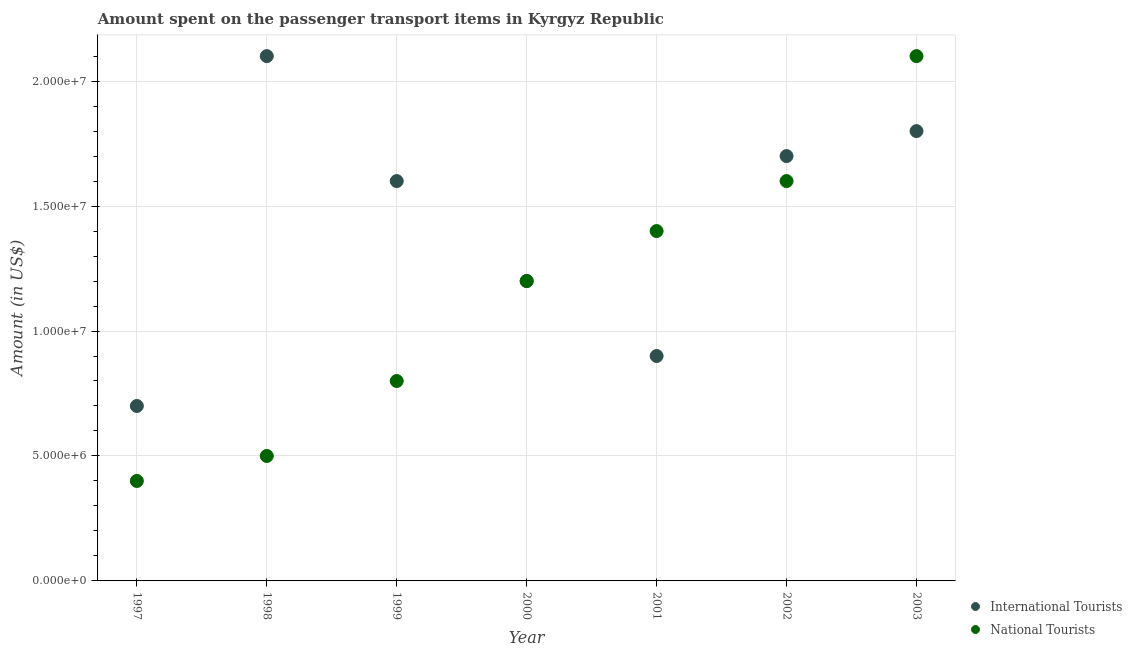Is the number of dotlines equal to the number of legend labels?
Make the answer very short. Yes. What is the amount spent on transport items of international tourists in 2001?
Provide a short and direct response. 9.00e+06. Across all years, what is the maximum amount spent on transport items of national tourists?
Your answer should be compact. 2.10e+07. Across all years, what is the minimum amount spent on transport items of national tourists?
Offer a very short reply. 4.00e+06. In which year was the amount spent on transport items of national tourists minimum?
Ensure brevity in your answer.  1997. What is the total amount spent on transport items of international tourists in the graph?
Provide a succinct answer. 1.00e+08. What is the difference between the amount spent on transport items of international tourists in 1997 and that in 2002?
Your response must be concise. -1.00e+07. What is the difference between the amount spent on transport items of national tourists in 2003 and the amount spent on transport items of international tourists in 1998?
Ensure brevity in your answer.  0. What is the average amount spent on transport items of international tourists per year?
Your response must be concise. 1.43e+07. In the year 1997, what is the difference between the amount spent on transport items of international tourists and amount spent on transport items of national tourists?
Make the answer very short. 3.00e+06. In how many years, is the amount spent on transport items of international tourists greater than 1000000 US$?
Ensure brevity in your answer.  7. Is the difference between the amount spent on transport items of national tourists in 1997 and 2001 greater than the difference between the amount spent on transport items of international tourists in 1997 and 2001?
Your response must be concise. No. What is the difference between the highest and the second highest amount spent on transport items of international tourists?
Ensure brevity in your answer.  3.00e+06. What is the difference between the highest and the lowest amount spent on transport items of national tourists?
Keep it short and to the point. 1.70e+07. In how many years, is the amount spent on transport items of national tourists greater than the average amount spent on transport items of national tourists taken over all years?
Offer a very short reply. 4. Is the sum of the amount spent on transport items of national tourists in 2002 and 2003 greater than the maximum amount spent on transport items of international tourists across all years?
Offer a terse response. Yes. Is the amount spent on transport items of international tourists strictly greater than the amount spent on transport items of national tourists over the years?
Provide a short and direct response. No. How many dotlines are there?
Keep it short and to the point. 2. What is the difference between two consecutive major ticks on the Y-axis?
Offer a terse response. 5.00e+06. Are the values on the major ticks of Y-axis written in scientific E-notation?
Ensure brevity in your answer.  Yes. Does the graph contain grids?
Provide a short and direct response. Yes. Where does the legend appear in the graph?
Offer a very short reply. Bottom right. How are the legend labels stacked?
Offer a terse response. Vertical. What is the title of the graph?
Offer a terse response. Amount spent on the passenger transport items in Kyrgyz Republic. What is the Amount (in US$) in International Tourists in 1997?
Your response must be concise. 7.00e+06. What is the Amount (in US$) in International Tourists in 1998?
Give a very brief answer. 2.10e+07. What is the Amount (in US$) of National Tourists in 1998?
Offer a very short reply. 5.00e+06. What is the Amount (in US$) of International Tourists in 1999?
Give a very brief answer. 1.60e+07. What is the Amount (in US$) of International Tourists in 2000?
Offer a terse response. 1.20e+07. What is the Amount (in US$) in International Tourists in 2001?
Offer a very short reply. 9.00e+06. What is the Amount (in US$) in National Tourists in 2001?
Provide a short and direct response. 1.40e+07. What is the Amount (in US$) in International Tourists in 2002?
Your response must be concise. 1.70e+07. What is the Amount (in US$) in National Tourists in 2002?
Your response must be concise. 1.60e+07. What is the Amount (in US$) in International Tourists in 2003?
Give a very brief answer. 1.80e+07. What is the Amount (in US$) of National Tourists in 2003?
Ensure brevity in your answer.  2.10e+07. Across all years, what is the maximum Amount (in US$) of International Tourists?
Provide a succinct answer. 2.10e+07. Across all years, what is the maximum Amount (in US$) in National Tourists?
Provide a succinct answer. 2.10e+07. Across all years, what is the minimum Amount (in US$) in International Tourists?
Your answer should be compact. 7.00e+06. Across all years, what is the minimum Amount (in US$) of National Tourists?
Provide a succinct answer. 4.00e+06. What is the total Amount (in US$) in International Tourists in the graph?
Ensure brevity in your answer.  1.00e+08. What is the total Amount (in US$) in National Tourists in the graph?
Make the answer very short. 8.00e+07. What is the difference between the Amount (in US$) in International Tourists in 1997 and that in 1998?
Ensure brevity in your answer.  -1.40e+07. What is the difference between the Amount (in US$) of National Tourists in 1997 and that in 1998?
Ensure brevity in your answer.  -1.00e+06. What is the difference between the Amount (in US$) in International Tourists in 1997 and that in 1999?
Give a very brief answer. -9.00e+06. What is the difference between the Amount (in US$) in National Tourists in 1997 and that in 1999?
Give a very brief answer. -4.00e+06. What is the difference between the Amount (in US$) of International Tourists in 1997 and that in 2000?
Your response must be concise. -5.00e+06. What is the difference between the Amount (in US$) in National Tourists in 1997 and that in 2000?
Provide a succinct answer. -8.00e+06. What is the difference between the Amount (in US$) in International Tourists in 1997 and that in 2001?
Provide a short and direct response. -2.00e+06. What is the difference between the Amount (in US$) of National Tourists in 1997 and that in 2001?
Your answer should be very brief. -1.00e+07. What is the difference between the Amount (in US$) of International Tourists in 1997 and that in 2002?
Provide a short and direct response. -1.00e+07. What is the difference between the Amount (in US$) in National Tourists in 1997 and that in 2002?
Offer a terse response. -1.20e+07. What is the difference between the Amount (in US$) in International Tourists in 1997 and that in 2003?
Make the answer very short. -1.10e+07. What is the difference between the Amount (in US$) of National Tourists in 1997 and that in 2003?
Give a very brief answer. -1.70e+07. What is the difference between the Amount (in US$) of International Tourists in 1998 and that in 1999?
Provide a short and direct response. 5.00e+06. What is the difference between the Amount (in US$) of International Tourists in 1998 and that in 2000?
Keep it short and to the point. 9.00e+06. What is the difference between the Amount (in US$) in National Tourists in 1998 and that in 2000?
Ensure brevity in your answer.  -7.00e+06. What is the difference between the Amount (in US$) of National Tourists in 1998 and that in 2001?
Offer a very short reply. -9.00e+06. What is the difference between the Amount (in US$) in National Tourists in 1998 and that in 2002?
Provide a short and direct response. -1.10e+07. What is the difference between the Amount (in US$) of International Tourists in 1998 and that in 2003?
Offer a terse response. 3.00e+06. What is the difference between the Amount (in US$) of National Tourists in 1998 and that in 2003?
Your answer should be compact. -1.60e+07. What is the difference between the Amount (in US$) of International Tourists in 1999 and that in 2000?
Give a very brief answer. 4.00e+06. What is the difference between the Amount (in US$) in National Tourists in 1999 and that in 2001?
Give a very brief answer. -6.00e+06. What is the difference between the Amount (in US$) in International Tourists in 1999 and that in 2002?
Offer a very short reply. -1.00e+06. What is the difference between the Amount (in US$) of National Tourists in 1999 and that in 2002?
Your answer should be compact. -8.00e+06. What is the difference between the Amount (in US$) of National Tourists in 1999 and that in 2003?
Give a very brief answer. -1.30e+07. What is the difference between the Amount (in US$) of International Tourists in 2000 and that in 2001?
Make the answer very short. 3.00e+06. What is the difference between the Amount (in US$) of National Tourists in 2000 and that in 2001?
Your response must be concise. -2.00e+06. What is the difference between the Amount (in US$) in International Tourists in 2000 and that in 2002?
Offer a terse response. -5.00e+06. What is the difference between the Amount (in US$) in National Tourists in 2000 and that in 2002?
Give a very brief answer. -4.00e+06. What is the difference between the Amount (in US$) in International Tourists in 2000 and that in 2003?
Provide a short and direct response. -6.00e+06. What is the difference between the Amount (in US$) of National Tourists in 2000 and that in 2003?
Your answer should be compact. -9.00e+06. What is the difference between the Amount (in US$) of International Tourists in 2001 and that in 2002?
Keep it short and to the point. -8.00e+06. What is the difference between the Amount (in US$) of National Tourists in 2001 and that in 2002?
Make the answer very short. -2.00e+06. What is the difference between the Amount (in US$) in International Tourists in 2001 and that in 2003?
Give a very brief answer. -9.00e+06. What is the difference between the Amount (in US$) in National Tourists in 2001 and that in 2003?
Provide a succinct answer. -7.00e+06. What is the difference between the Amount (in US$) in National Tourists in 2002 and that in 2003?
Offer a very short reply. -5.00e+06. What is the difference between the Amount (in US$) in International Tourists in 1997 and the Amount (in US$) in National Tourists in 1998?
Your answer should be very brief. 2.00e+06. What is the difference between the Amount (in US$) of International Tourists in 1997 and the Amount (in US$) of National Tourists in 1999?
Give a very brief answer. -1.00e+06. What is the difference between the Amount (in US$) of International Tourists in 1997 and the Amount (in US$) of National Tourists in 2000?
Give a very brief answer. -5.00e+06. What is the difference between the Amount (in US$) of International Tourists in 1997 and the Amount (in US$) of National Tourists in 2001?
Offer a terse response. -7.00e+06. What is the difference between the Amount (in US$) of International Tourists in 1997 and the Amount (in US$) of National Tourists in 2002?
Your answer should be very brief. -9.00e+06. What is the difference between the Amount (in US$) of International Tourists in 1997 and the Amount (in US$) of National Tourists in 2003?
Make the answer very short. -1.40e+07. What is the difference between the Amount (in US$) of International Tourists in 1998 and the Amount (in US$) of National Tourists in 1999?
Make the answer very short. 1.30e+07. What is the difference between the Amount (in US$) in International Tourists in 1998 and the Amount (in US$) in National Tourists in 2000?
Make the answer very short. 9.00e+06. What is the difference between the Amount (in US$) in International Tourists in 1999 and the Amount (in US$) in National Tourists in 2000?
Make the answer very short. 4.00e+06. What is the difference between the Amount (in US$) of International Tourists in 1999 and the Amount (in US$) of National Tourists in 2001?
Provide a short and direct response. 2.00e+06. What is the difference between the Amount (in US$) in International Tourists in 1999 and the Amount (in US$) in National Tourists in 2003?
Provide a succinct answer. -5.00e+06. What is the difference between the Amount (in US$) in International Tourists in 2000 and the Amount (in US$) in National Tourists in 2001?
Your answer should be very brief. -2.00e+06. What is the difference between the Amount (in US$) of International Tourists in 2000 and the Amount (in US$) of National Tourists in 2002?
Your answer should be very brief. -4.00e+06. What is the difference between the Amount (in US$) in International Tourists in 2000 and the Amount (in US$) in National Tourists in 2003?
Offer a very short reply. -9.00e+06. What is the difference between the Amount (in US$) of International Tourists in 2001 and the Amount (in US$) of National Tourists in 2002?
Provide a succinct answer. -7.00e+06. What is the difference between the Amount (in US$) in International Tourists in 2001 and the Amount (in US$) in National Tourists in 2003?
Make the answer very short. -1.20e+07. What is the average Amount (in US$) of International Tourists per year?
Give a very brief answer. 1.43e+07. What is the average Amount (in US$) of National Tourists per year?
Keep it short and to the point. 1.14e+07. In the year 1997, what is the difference between the Amount (in US$) of International Tourists and Amount (in US$) of National Tourists?
Offer a terse response. 3.00e+06. In the year 1998, what is the difference between the Amount (in US$) in International Tourists and Amount (in US$) in National Tourists?
Provide a short and direct response. 1.60e+07. In the year 2000, what is the difference between the Amount (in US$) in International Tourists and Amount (in US$) in National Tourists?
Your answer should be compact. 0. In the year 2001, what is the difference between the Amount (in US$) of International Tourists and Amount (in US$) of National Tourists?
Your answer should be compact. -5.00e+06. In the year 2002, what is the difference between the Amount (in US$) of International Tourists and Amount (in US$) of National Tourists?
Offer a very short reply. 1.00e+06. In the year 2003, what is the difference between the Amount (in US$) in International Tourists and Amount (in US$) in National Tourists?
Make the answer very short. -3.00e+06. What is the ratio of the Amount (in US$) of International Tourists in 1997 to that in 1998?
Your response must be concise. 0.33. What is the ratio of the Amount (in US$) in National Tourists in 1997 to that in 1998?
Ensure brevity in your answer.  0.8. What is the ratio of the Amount (in US$) of International Tourists in 1997 to that in 1999?
Your answer should be compact. 0.44. What is the ratio of the Amount (in US$) of National Tourists in 1997 to that in 1999?
Keep it short and to the point. 0.5. What is the ratio of the Amount (in US$) in International Tourists in 1997 to that in 2000?
Ensure brevity in your answer.  0.58. What is the ratio of the Amount (in US$) of National Tourists in 1997 to that in 2001?
Provide a succinct answer. 0.29. What is the ratio of the Amount (in US$) in International Tourists in 1997 to that in 2002?
Your response must be concise. 0.41. What is the ratio of the Amount (in US$) of International Tourists in 1997 to that in 2003?
Give a very brief answer. 0.39. What is the ratio of the Amount (in US$) of National Tourists in 1997 to that in 2003?
Your response must be concise. 0.19. What is the ratio of the Amount (in US$) of International Tourists in 1998 to that in 1999?
Make the answer very short. 1.31. What is the ratio of the Amount (in US$) in National Tourists in 1998 to that in 2000?
Keep it short and to the point. 0.42. What is the ratio of the Amount (in US$) of International Tourists in 1998 to that in 2001?
Ensure brevity in your answer.  2.33. What is the ratio of the Amount (in US$) of National Tourists in 1998 to that in 2001?
Your response must be concise. 0.36. What is the ratio of the Amount (in US$) in International Tourists in 1998 to that in 2002?
Give a very brief answer. 1.24. What is the ratio of the Amount (in US$) in National Tourists in 1998 to that in 2002?
Make the answer very short. 0.31. What is the ratio of the Amount (in US$) of International Tourists in 1998 to that in 2003?
Your response must be concise. 1.17. What is the ratio of the Amount (in US$) in National Tourists in 1998 to that in 2003?
Your answer should be compact. 0.24. What is the ratio of the Amount (in US$) in International Tourists in 1999 to that in 2001?
Your response must be concise. 1.78. What is the ratio of the Amount (in US$) of National Tourists in 1999 to that in 2003?
Make the answer very short. 0.38. What is the ratio of the Amount (in US$) of International Tourists in 2000 to that in 2001?
Make the answer very short. 1.33. What is the ratio of the Amount (in US$) in International Tourists in 2000 to that in 2002?
Make the answer very short. 0.71. What is the ratio of the Amount (in US$) of International Tourists in 2000 to that in 2003?
Give a very brief answer. 0.67. What is the ratio of the Amount (in US$) of International Tourists in 2001 to that in 2002?
Make the answer very short. 0.53. What is the ratio of the Amount (in US$) in National Tourists in 2001 to that in 2002?
Ensure brevity in your answer.  0.88. What is the ratio of the Amount (in US$) in National Tourists in 2001 to that in 2003?
Ensure brevity in your answer.  0.67. What is the ratio of the Amount (in US$) in International Tourists in 2002 to that in 2003?
Make the answer very short. 0.94. What is the ratio of the Amount (in US$) in National Tourists in 2002 to that in 2003?
Your answer should be compact. 0.76. What is the difference between the highest and the second highest Amount (in US$) of International Tourists?
Give a very brief answer. 3.00e+06. What is the difference between the highest and the lowest Amount (in US$) of International Tourists?
Your answer should be very brief. 1.40e+07. What is the difference between the highest and the lowest Amount (in US$) in National Tourists?
Ensure brevity in your answer.  1.70e+07. 